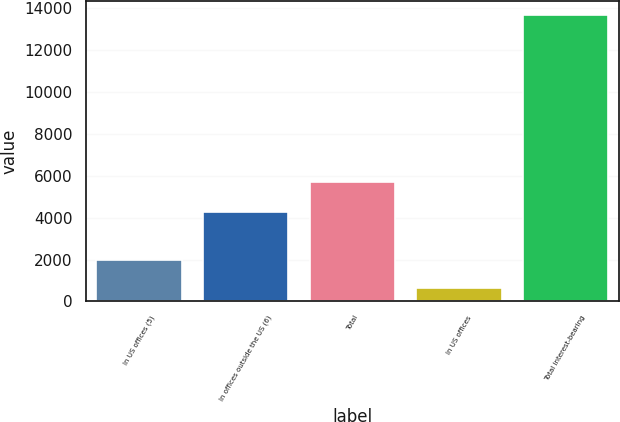Convert chart. <chart><loc_0><loc_0><loc_500><loc_500><bar_chart><fcel>In US offices (5)<fcel>In offices outside the US (6)<fcel>Total<fcel>In US offices<fcel>Total interest-bearing<nl><fcel>1959.4<fcel>4260<fcel>5692<fcel>656<fcel>13690<nl></chart> 